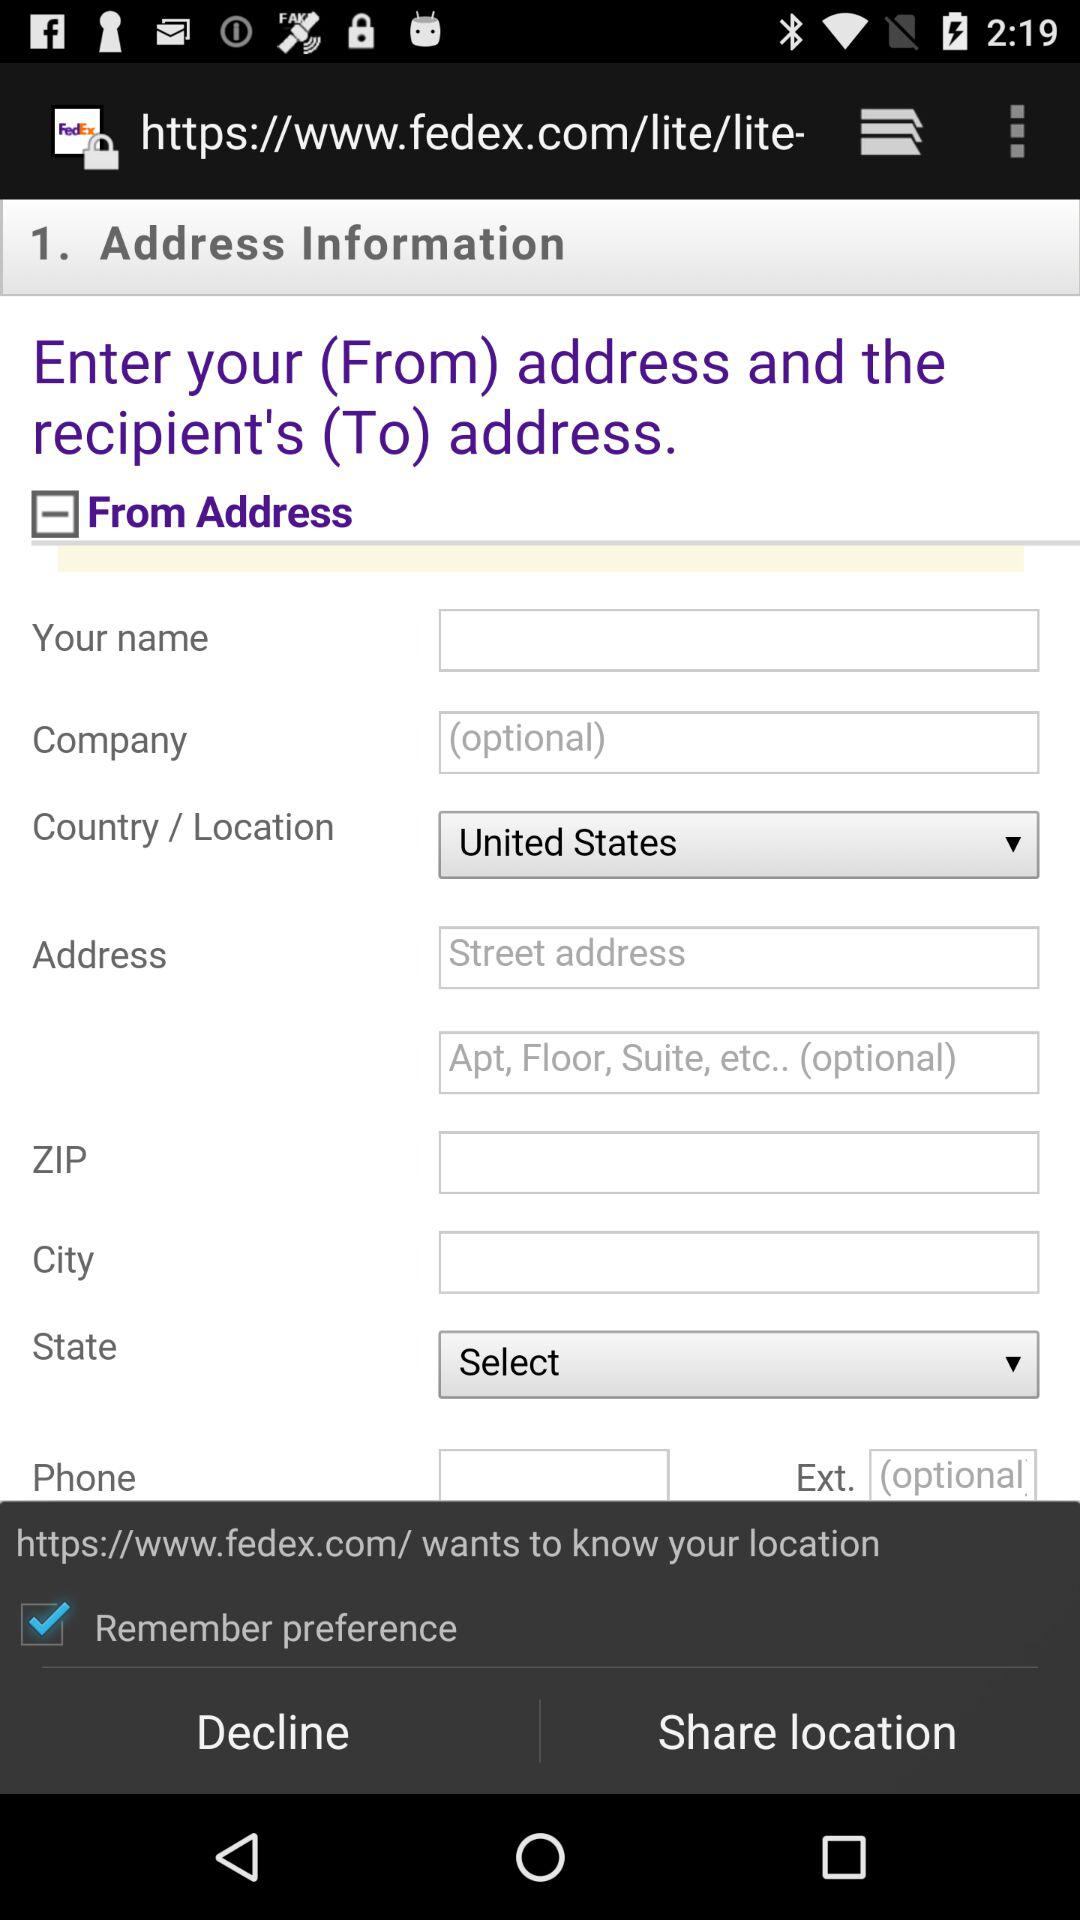What's the country? The country is the United States. 